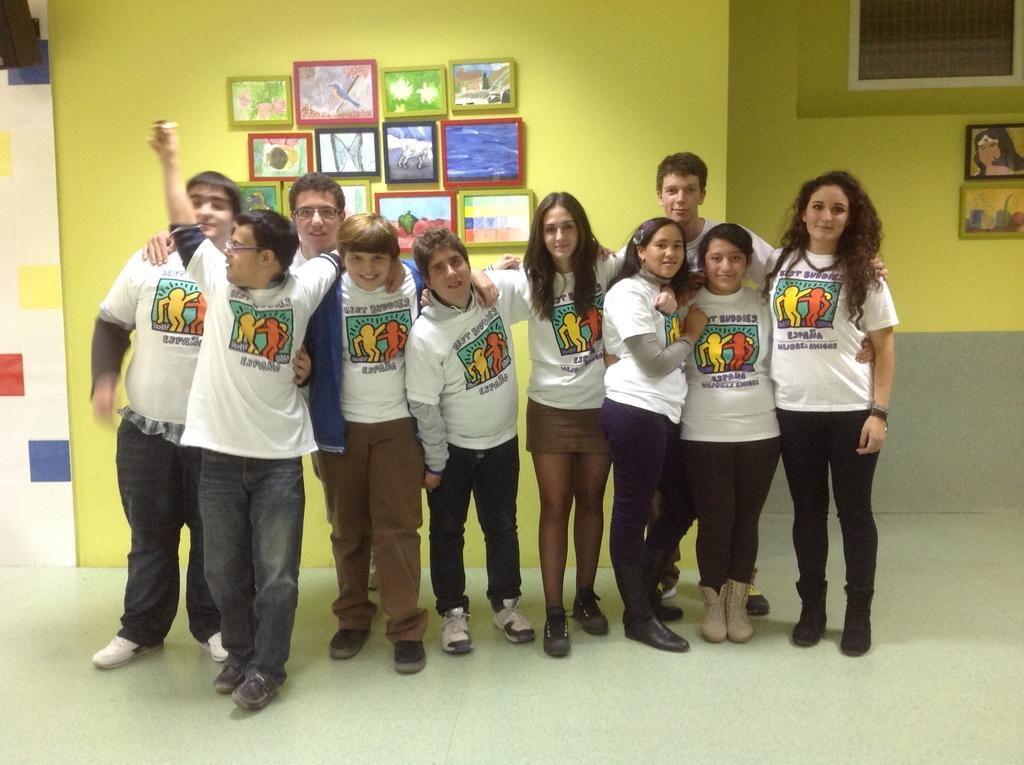How would you summarize this image in a sentence or two? In this picture there are group of persons standing and smiling. In the background on the wall there are frames and the wall is yellow in colour. 